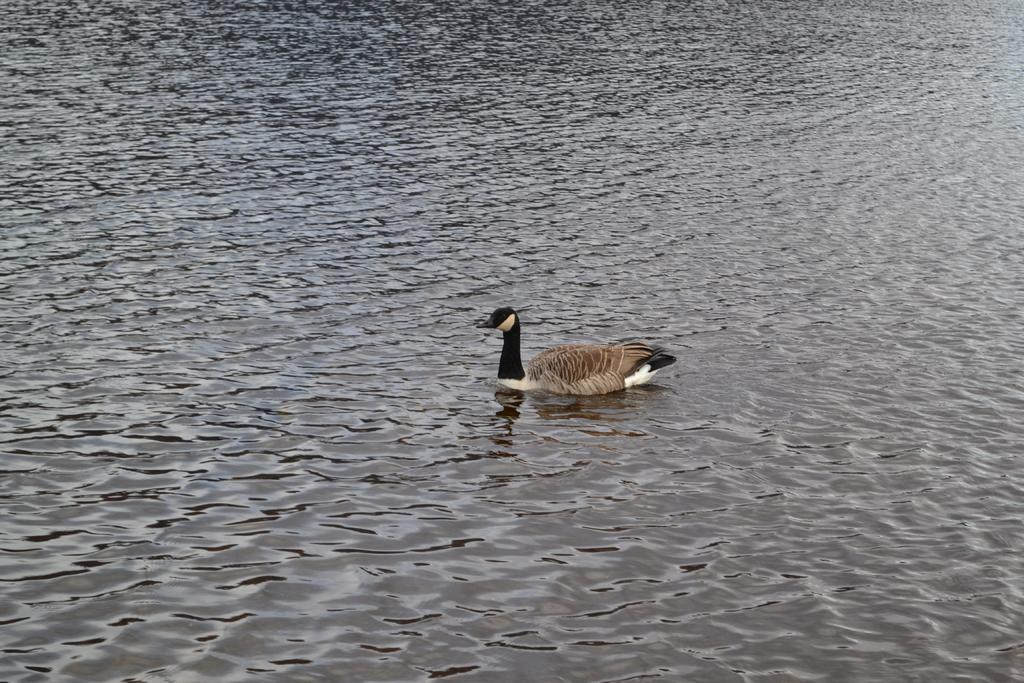What animal is present in the image? There is a duck in the image. What is the duck doing in the image? The duck is swimming in the water. What type of thread is being used to sew the mark on the border in the image? There is no thread, mark, or border present in the image; it only features a duck swimming in the water. 